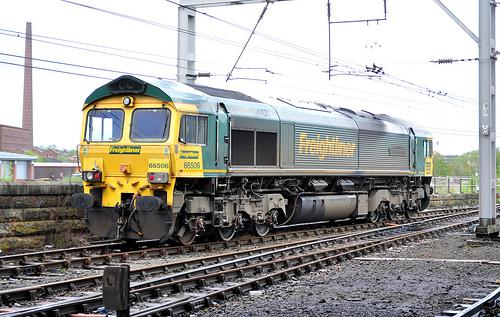Question: what color is train?
Choices:
A. Red.
B. Red and blue.
C. Grey and black.
D. Yellow and Green.
Answer with the letter. Answer: D Question: how many cars on train?
Choices:
A. Two.
B. Three.
C. One.
D. Four.
Answer with the letter. Answer: C Question: where is train?
Choices:
A. Parked.
B. Moving along.
C. On the ground.
D. Train tracks.
Answer with the letter. Answer: D 